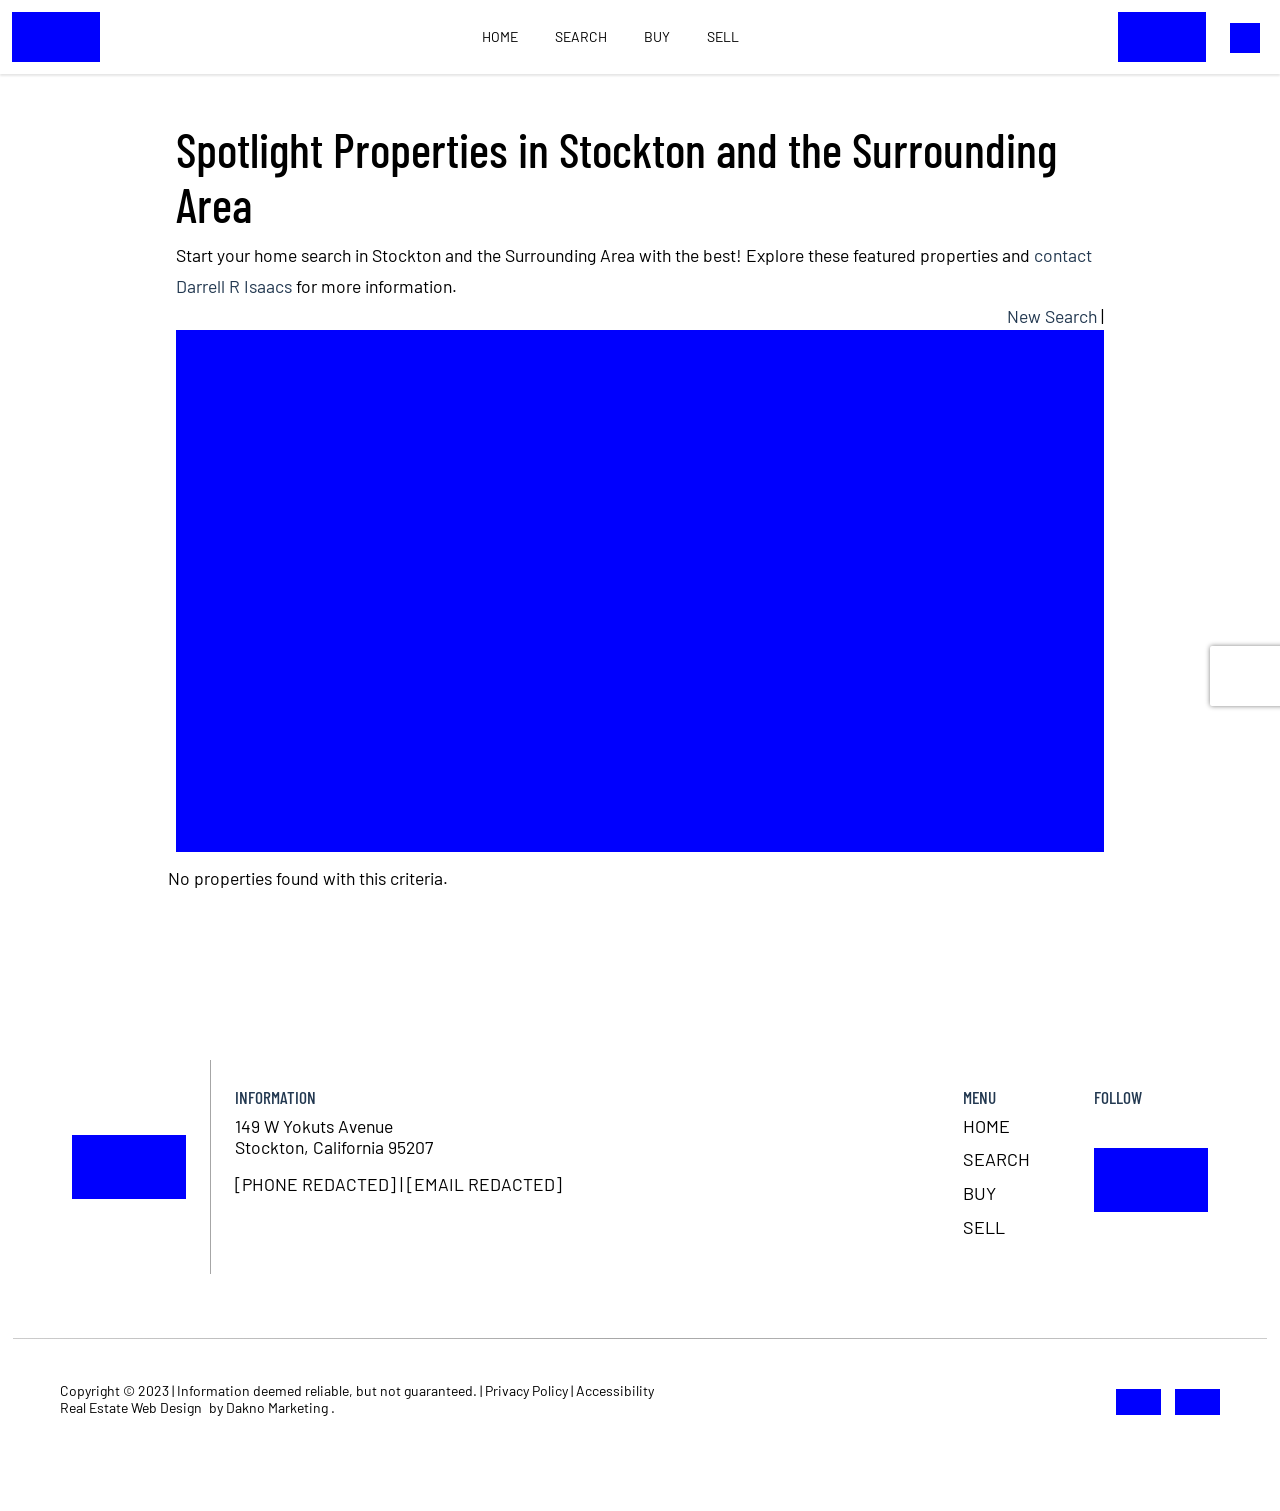What are some key features to consider when listing a property in this area on a website like the one depicted? When listing a property in this area on a website, consider highlighting key features such as proximity to local amenities, ease of access, neighborhood safety ratings, and local schools' quality. It's also effective to include high-quality images, virtual tours, and a clear and enticing property description. Providing detailed information about the property's size, room dimensions, and unique features, such as energy-efficient installations or recent renovations, will make the listing more attractive to potential buyers. 